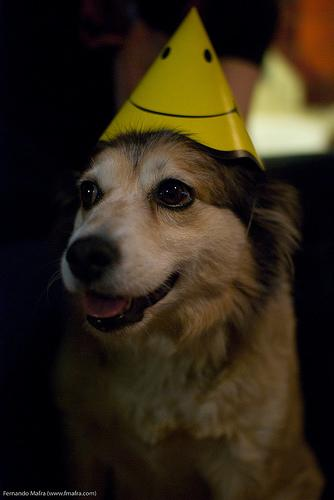List three distinct features of the dog's face that are visible in the image. The dog's tongue sticking out, large black eye, and small whiskers on the face. Which among these objects is present on the hat: a white band, a black band, or a green band? A thin white band is attached to the hat. Identify the type of animal in the image and mention the color of its fur. This is a dog with brown and white fur. What is the color and shape of the dog's nose? The dog's nose is black and the shape is not clearly visible. What is the dominant feature of the dog's face and its color? The dominant feature of the dog's face is its big black eyes and pink tongue sticking out. Mention one unique attribute of the dog's hat and describe its appearance. The hat has a smiling yellow face with black spots on it. What type of hat does the dog wear and what is its color? The dog is wearing a yellow party hat which is cone-shaped. Describe the imagery that might be implied by the dog wearing a party hat. The image suggests the dog is in a celebratory or festive mood, perhaps attending a party or event. What aspect of the dog makes it look happy in this image? The dog's tongue is sticking out, giving it a happy appearance. 